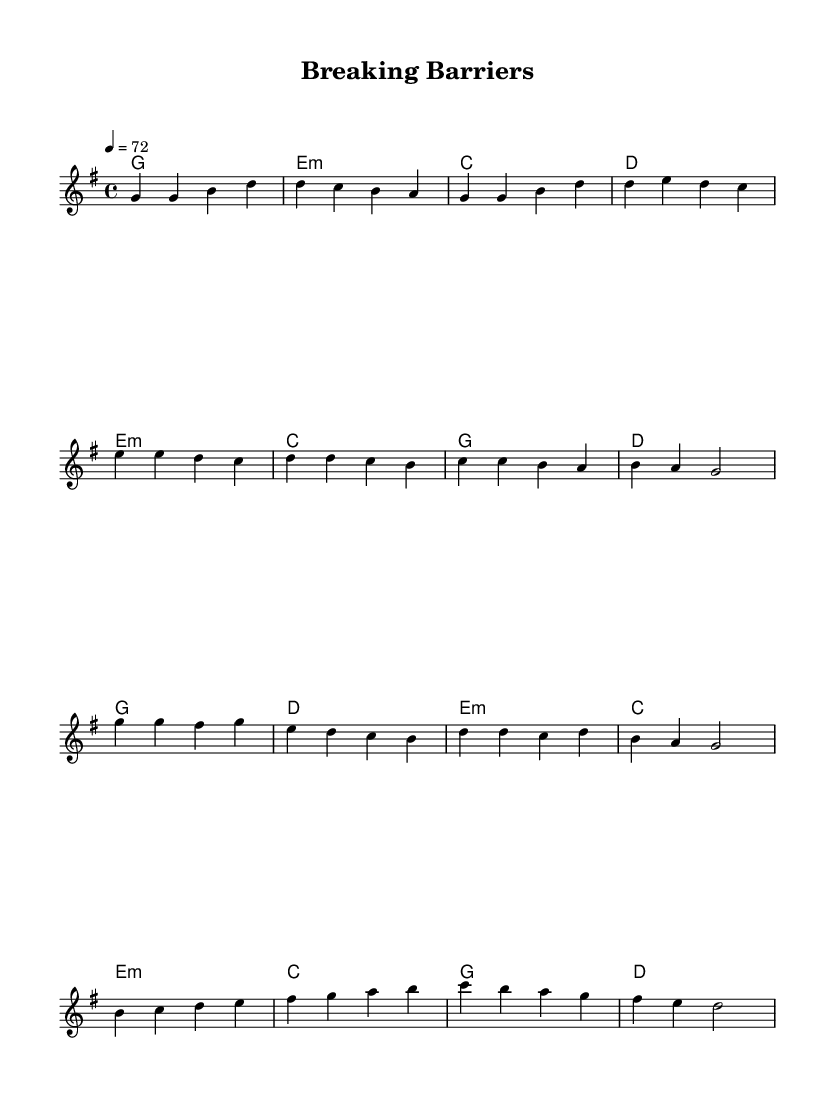What is the key signature of this music? The key signature is G major, which has one sharp (F sharp).
Answer: G major What is the time signature of this music? The time signature is indicated at the beginning of the score, which is 4/4, meaning four beats per measure.
Answer: 4/4 What is the tempo marking? The tempo marking indicates the pace of the music, which is set to 72 beats per minute in a quarter note.
Answer: 72 How many measures are in the melody section? The melody is divided into different sections: the verse has 4 measures, the pre-chorus has 4 measures, the chorus has 4 measures, and the bridge has 4 measures, totaling 16 measures.
Answer: 16 What chord follows the F sharp in the chorus? In the chorus, the chord that follows F sharp is E minor based on the chord progression for that section.
Answer: E minor How does the bridge section differ from the verse in terms of chords? The bridge incorporates a more varied harmonic progression, moving through E minor, C, G, and D, creating a contrast to the more static harmony of the verse.
Answer: More varied harmonic progression What theme does the title "Breaking Barriers" suggest? The title implies a theme of overcoming obstacles and personal challenges, resonating with the empowering ballad style typical in Pop music.
Answer: Overcoming obstacles 